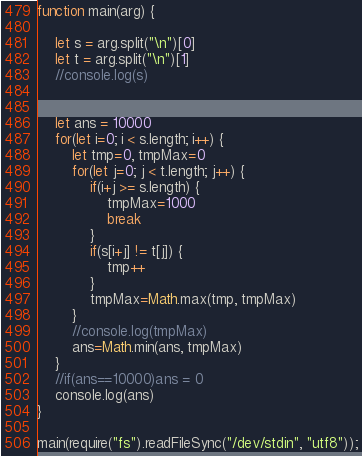Convert code to text. <code><loc_0><loc_0><loc_500><loc_500><_JavaScript_>function main(arg) {
    
    let s = arg.split("\n")[0]
    let t = arg.split("\n")[1]
    //console.log(s)
    
    
    let ans = 10000
    for(let i=0; i < s.length; i++) {
        let tmp=0, tmpMax=0
        for(let j=0; j < t.length; j++) {
            if(i+j >= s.length) {
                tmpMax=1000
                break
            }
            if(s[i+j] != t[j]) {
                tmp++
            }
            tmpMax=Math.max(tmp, tmpMax)
        }
        //console.log(tmpMax)
        ans=Math.min(ans, tmpMax)
    }
    //if(ans==10000)ans = 0
    console.log(ans)
}

main(require("fs").readFileSync("/dev/stdin", "utf8"));
</code> 